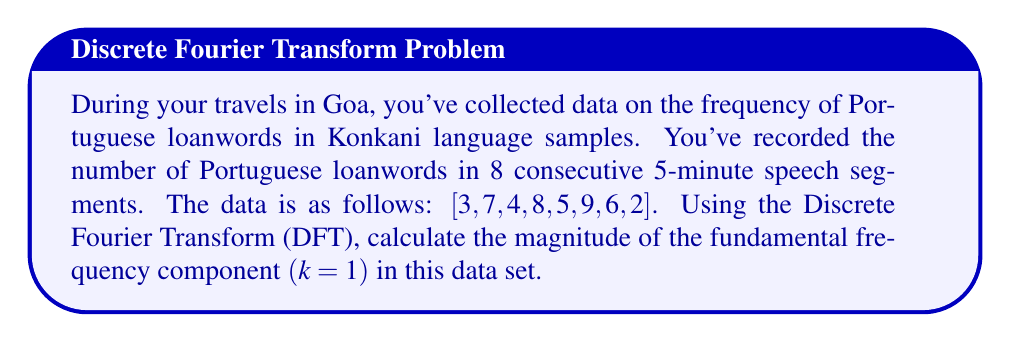Show me your answer to this math problem. To solve this problem, we'll follow these steps:

1) The Discrete Fourier Transform for a sequence x[n] of length N is given by:

   $$X[k] = \sum_{n=0}^{N-1} x[n] e^{-i2\pi kn/N}$$

2) For k=1 (fundamental frequency), this becomes:

   $$X[1] = \sum_{n=0}^{7} x[n] e^{-i2\pi n/8}$$

3) Let's break this into real and imaginary parts:

   $$X[1] = \sum_{n=0}^{7} x[n] (\cos(2\pi n/8) - i\sin(2\pi n/8))$$

4) Now, let's calculate for each n:

   n=0: $3 (\cos(0) - i\sin(0)) = 3$
   n=1: $7 (\cos(\pi/4) - i\sin(\pi/4)) = 7(0.7071 - 0.7071i)$
   n=2: $4 (\cos(\pi/2) - i\sin(\pi/2)) = -4i$
   n=3: $8 (\cos(3\pi/4) - i\sin(3\pi/4)) = 8(-0.7071 - 0.7071i)$
   n=4: $5 (\cos(\pi) - i\sin(\pi)) = -5$
   n=5: $9 (\cos(5\pi/4) - i\sin(5\pi/4)) = 9(-0.7071 + 0.7071i)$
   n=6: $6 (\cos(3\pi/2) - i\sin(3\pi/2)) = 6i$
   n=7: $2 (\cos(7\pi/4) - i\sin(7\pi/4)) = 2(0.7071 + 0.7071i)$

5) Sum these up:

   $$X[1] = (3 - 5) + (4.9497 - 5.6568 + 6.3639 + 1.4142)$$
          $$+ (-4 - 5.6568 + 6 + 1.4142)i$$
        $$= 5.0710 - 2.2426i$$

6) The magnitude of this complex number is:

   $$|X[1]| = \sqrt{(5.0710)^2 + (-2.2426)^2} = 5.5433$$
Answer: $5.5433$ 